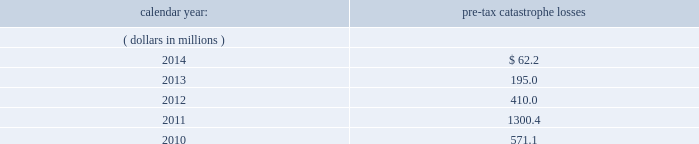Available information .
The company 2019s annual reports on form 10-k , quarterly reports on form 10-q , current reports on form 8- k , proxy statements and amendments to those reports are available free of charge through the company 2019s internet website at http://www.everestregroup.com as soon as reasonably practicable after such reports are electronically filed with the securities and exchange commission ( the 201csec 201d ) .
Item 1a .
Risk factors in addition to the other information provided in this report , the following risk factors should be considered when evaluating an investment in our securities .
If the circumstances contemplated by the individual risk factors materialize , our business , financial condition and results of operations could be materially and adversely affected and the trading price of our common shares could decline significantly .
Risks relating to our business fluctuations in the financial markets could result in investment losses .
Prolonged and severe disruptions in the overall public debt and equity markets , such as occurred during 2008 , could result in significant realized and unrealized losses in our investment portfolio .
Although financial markets have significantly improved since 2008 , they could deteriorate in the future .
There could also be disruption in individual market sectors , such as occurred in the energy sector during the fourth quarter of 2014 .
Such declines in the financial markets could result in significant realized and unrealized losses on investments and could have a material adverse impact on our results of operations , equity , business and insurer financial strength and debt ratings .
Our results could be adversely affected by catastrophic events .
We are exposed to unpredictable catastrophic events , including weather-related and other natural catastrophes , as well as acts of terrorism .
Any material reduction in our operating results caused by the occurrence of one or more catastrophes could inhibit our ability to pay dividends or to meet our interest and principal payment obligations .
Subsequent to april 1 , 2010 , we define a catastrophe as an event that causes a loss on property exposures before reinsurance of at least $ 10.0 million , before corporate level reinsurance and taxes .
Prior to april 1 , 2010 , we used a threshold of $ 5.0 million .
By way of illustration , during the past five calendar years , pre-tax catastrophe losses , net of contract specific reinsurance but before cessions under corporate reinsurance programs , were as follows: .
Our losses from future catastrophic events could exceed our projections .
We use projections of possible losses from future catastrophic events of varying types and magnitudes as a strategic underwriting tool .
We use these loss projections to estimate our potential catastrophe losses in certain geographic areas and decide on the placement of retrocessional coverage or other actions to limit the extent of potential losses in a given geographic area .
These loss projections are approximations , reliant on a mix of quantitative and qualitative processes , and actual losses may exceed the projections by a material amount , resulting in a material adverse effect on our financial condition and results of operations. .
What are the total pre-tax catastrophe losses in the last 3 years?\\n? 
Computations: ((62.2 + 195.0) + 410.0)
Answer: 667.2. 